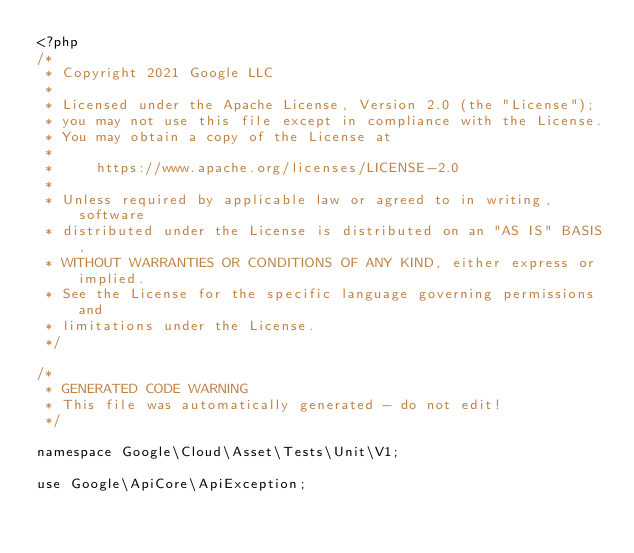Convert code to text. <code><loc_0><loc_0><loc_500><loc_500><_PHP_><?php
/*
 * Copyright 2021 Google LLC
 *
 * Licensed under the Apache License, Version 2.0 (the "License");
 * you may not use this file except in compliance with the License.
 * You may obtain a copy of the License at
 *
 *     https://www.apache.org/licenses/LICENSE-2.0
 *
 * Unless required by applicable law or agreed to in writing, software
 * distributed under the License is distributed on an "AS IS" BASIS,
 * WITHOUT WARRANTIES OR CONDITIONS OF ANY KIND, either express or implied.
 * See the License for the specific language governing permissions and
 * limitations under the License.
 */

/*
 * GENERATED CODE WARNING
 * This file was automatically generated - do not edit!
 */

namespace Google\Cloud\Asset\Tests\Unit\V1;

use Google\ApiCore\ApiException;
</code> 